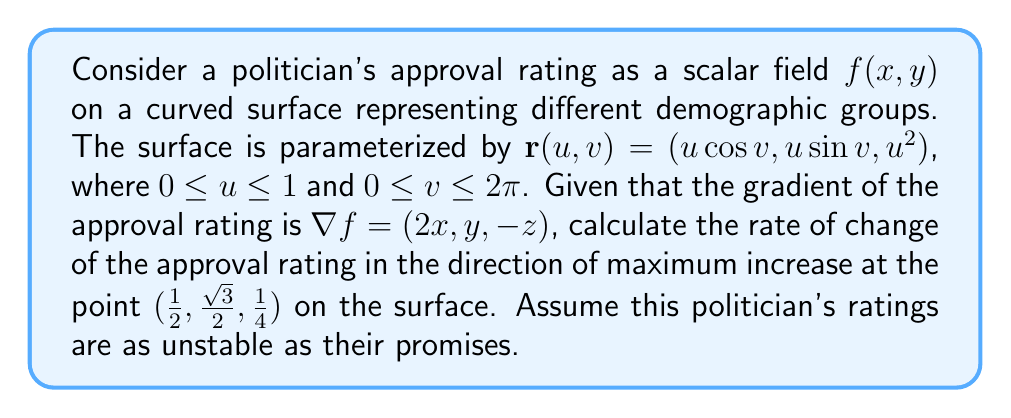Can you solve this math problem? Let's approach this step-by-step:

1) First, we need to find the tangent plane to the surface at the given point. The tangent vectors are:

   $\mathbf{r}_u = (\cos v, \sin v, 2u)$
   $\mathbf{r}_v = (-u\sin v, u\cos v, 0)$

2) At the point $(1/2, \sqrt{3}/2, 1/4)$, we have $u = 1/2$ and $v = \pi/3$. Substituting these values:

   $\mathbf{r}_u = (1/2, \sqrt{3}/2, 1)$
   $\mathbf{r}_v = (-\sqrt{3}/4, 1/4, 0)$

3) The normal vector to the surface is given by the cross product:

   $\mathbf{N} = \mathbf{r}_u \times \mathbf{r}_v = (-\sqrt{3}/4, -1/4, 5/4)$

4) The gradient of $f$ at the given point is:

   $\nabla f = (1, \sqrt{3}/2, -1/4)$

5) To find the direction of maximum increase on the surface, we need to project this gradient onto the tangent plane and normalize it:

   $\nabla_S f = \nabla f - (\nabla f \cdot \hat{\mathbf{N}})\hat{\mathbf{N}}$

   where $\hat{\mathbf{N}}$ is the unit normal vector.

6) Calculating $\hat{\mathbf{N}}$:

   $\|\mathbf{N}\| = \sqrt{(-\sqrt{3}/4)^2 + (-1/4)^2 + (5/4)^2} = \sqrt{35}/4$

   $\hat{\mathbf{N}} = (-\sqrt{3}/\sqrt{35}, -1/\sqrt{35}, 5/\sqrt{35})$

7) Now, $\nabla f \cdot \hat{\mathbf{N}} = (-\sqrt{3} + \sqrt{3}/2 - 5/4) / \sqrt{35} = -5/(2\sqrt{35})$

8) Therefore,

   $\nabla_S f = (1, \sqrt{3}/2, -1/4) + (5/(2\sqrt{35}))(-\sqrt{3}/\sqrt{35}, -1/\sqrt{35}, 5/\sqrt{35})$
               $= (1 - 15/(14\sqrt{35}), \sqrt{3}/2 - 5/(14\sqrt{35}), -1/4 + 25/(14\sqrt{35}))$

9) The magnitude of this vector gives the rate of change in the direction of maximum increase:

   $\|\nabla_S f\| = \sqrt{(1 - 15/(14\sqrt{35}))^2 + (\sqrt{3}/2 - 5/(14\sqrt{35}))^2 + (-1/4 + 25/(14\sqrt{35}))^2}$
Answer: $\sqrt{(1 - 15/(14\sqrt{35}))^2 + (\sqrt{3}/2 - 5/(14\sqrt{35}))^2 + (-1/4 + 25/(14\sqrt{35}))^2}$ 